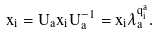<formula> <loc_0><loc_0><loc_500><loc_500>x _ { i } = U _ { a } x _ { i } U _ { a } ^ { - 1 } = x _ { i } \lambda _ { a } ^ { q _ { i } ^ { a } } .</formula> 